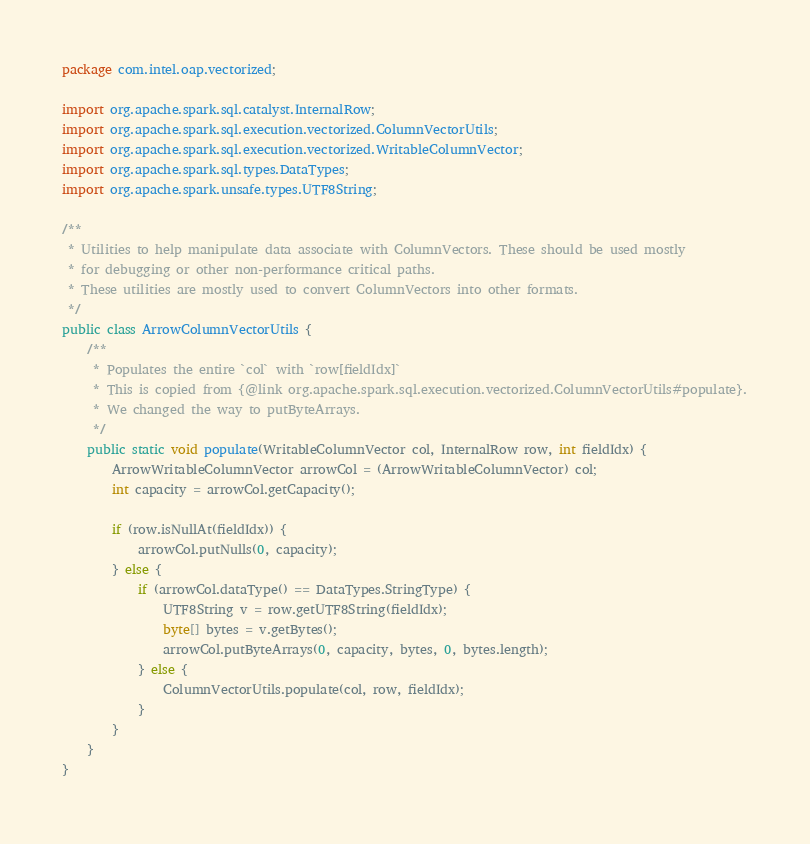<code> <loc_0><loc_0><loc_500><loc_500><_Java_>package com.intel.oap.vectorized;

import org.apache.spark.sql.catalyst.InternalRow;
import org.apache.spark.sql.execution.vectorized.ColumnVectorUtils;
import org.apache.spark.sql.execution.vectorized.WritableColumnVector;
import org.apache.spark.sql.types.DataTypes;
import org.apache.spark.unsafe.types.UTF8String;

/**
 * Utilities to help manipulate data associate with ColumnVectors. These should be used mostly
 * for debugging or other non-performance critical paths.
 * These utilities are mostly used to convert ColumnVectors into other formats.
 */
public class ArrowColumnVectorUtils {
    /**
     * Populates the entire `col` with `row[fieldIdx]`
     * This is copied from {@link org.apache.spark.sql.execution.vectorized.ColumnVectorUtils#populate}.
     * We changed the way to putByteArrays.
     */
    public static void populate(WritableColumnVector col, InternalRow row, int fieldIdx) {
        ArrowWritableColumnVector arrowCol = (ArrowWritableColumnVector) col;
        int capacity = arrowCol.getCapacity();

        if (row.isNullAt(fieldIdx)) {
            arrowCol.putNulls(0, capacity);
        } else {
            if (arrowCol.dataType() == DataTypes.StringType) {
                UTF8String v = row.getUTF8String(fieldIdx);
                byte[] bytes = v.getBytes();
                arrowCol.putByteArrays(0, capacity, bytes, 0, bytes.length);
            } else {
                ColumnVectorUtils.populate(col, row, fieldIdx);
            }
        }
    }
}
</code> 